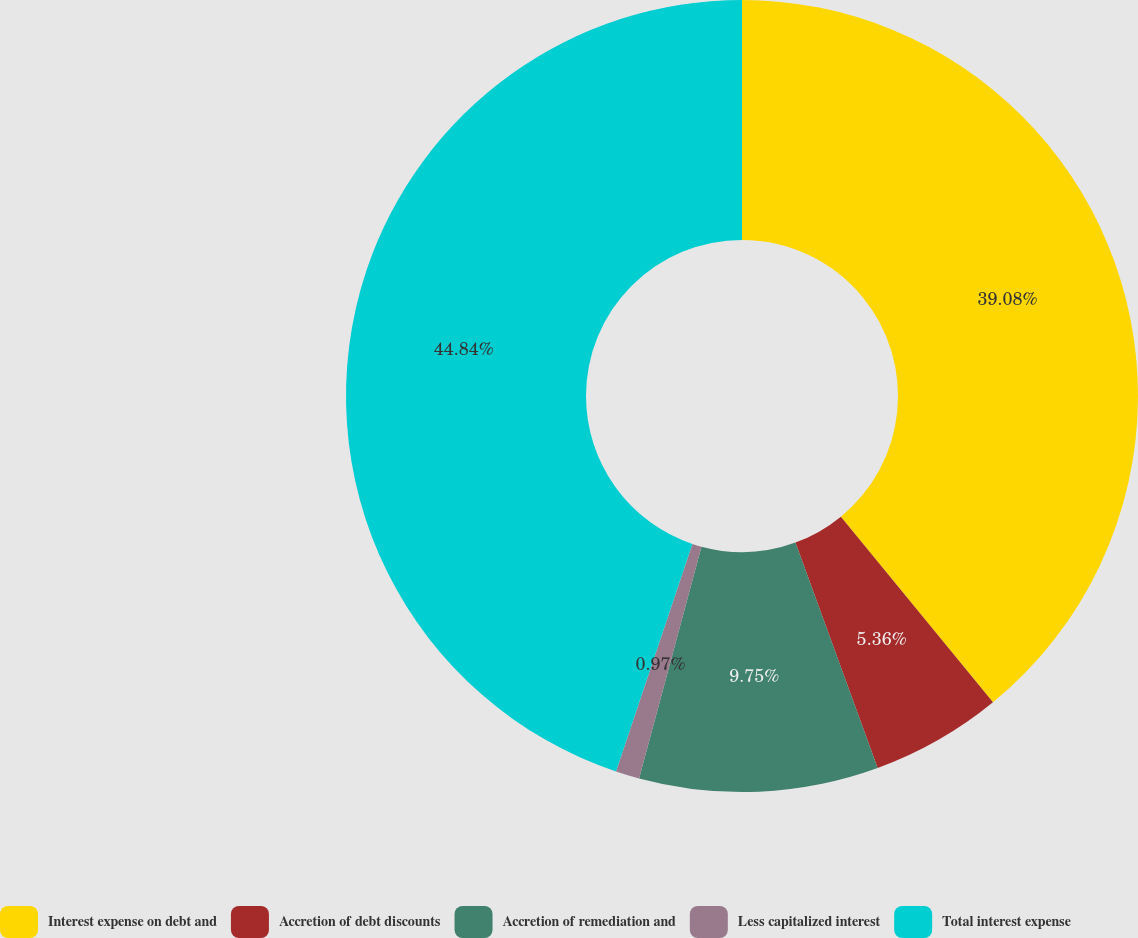Convert chart to OTSL. <chart><loc_0><loc_0><loc_500><loc_500><pie_chart><fcel>Interest expense on debt and<fcel>Accretion of debt discounts<fcel>Accretion of remediation and<fcel>Less capitalized interest<fcel>Total interest expense<nl><fcel>39.08%<fcel>5.36%<fcel>9.75%<fcel>0.97%<fcel>44.85%<nl></chart> 